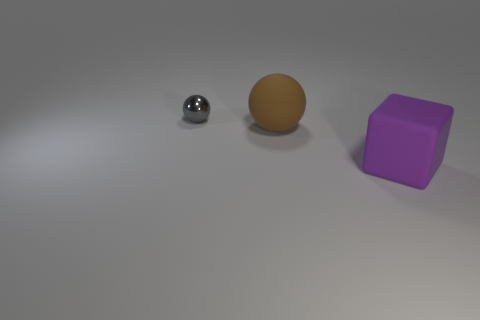Can you analyze the lighting and shadows in the scene? Certainly. The scene is softly lit, likely from a wide light source above the objects, as indicated by the diffuse shadows. The shadows are relatively soft and extend primarily to the right of the objects, suggesting that the light source is positioned to the left. The metallic sphere reflects the most light and has the brightest highlight, while the matte ball shows more subdued lighting due to its non-reflective surface. 